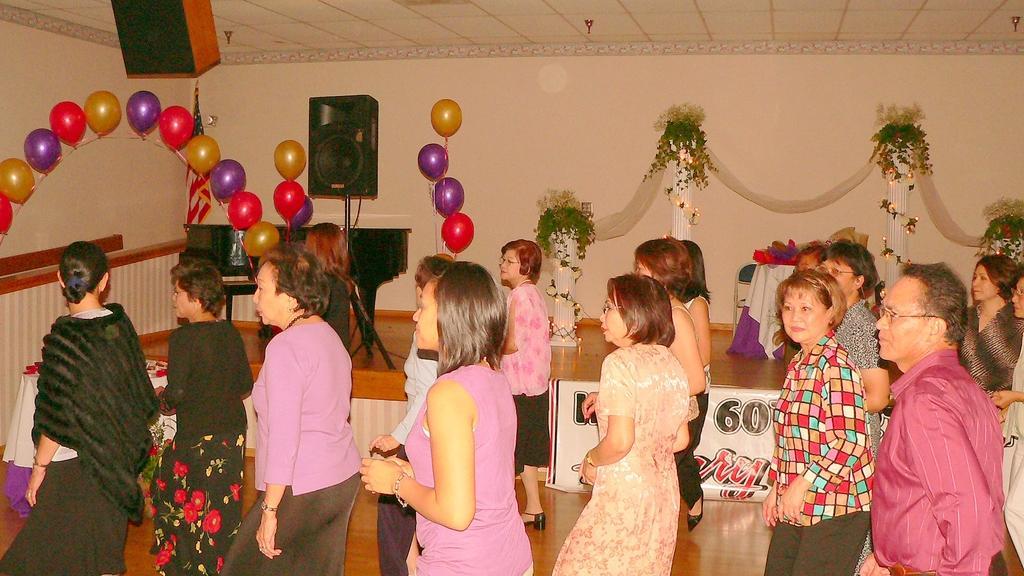Please provide a concise description of this image. In the image we can see there are people around, they are wearing clothes and some of them are wearing spectacles. This is a wooden surface, wall, balloons, pillars, plant, sound box and a flower. 